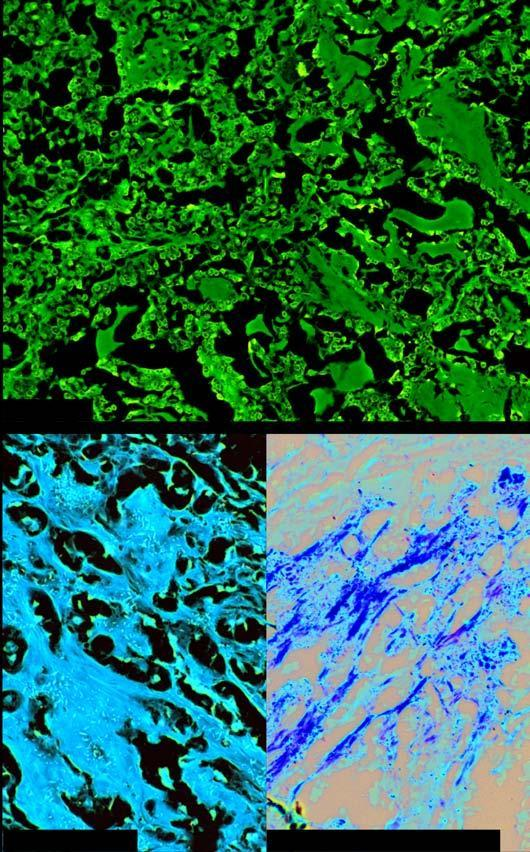what shows organoid pattern of oval tumour cells and abundant amyloid stroma?
Answer the question using a single word or phrase. Microscopy 